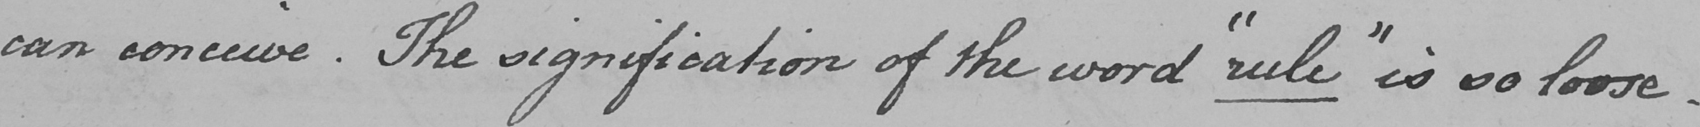Please transcribe the handwritten text in this image. can conceive . The signification of the world  " rule "  is so loose 